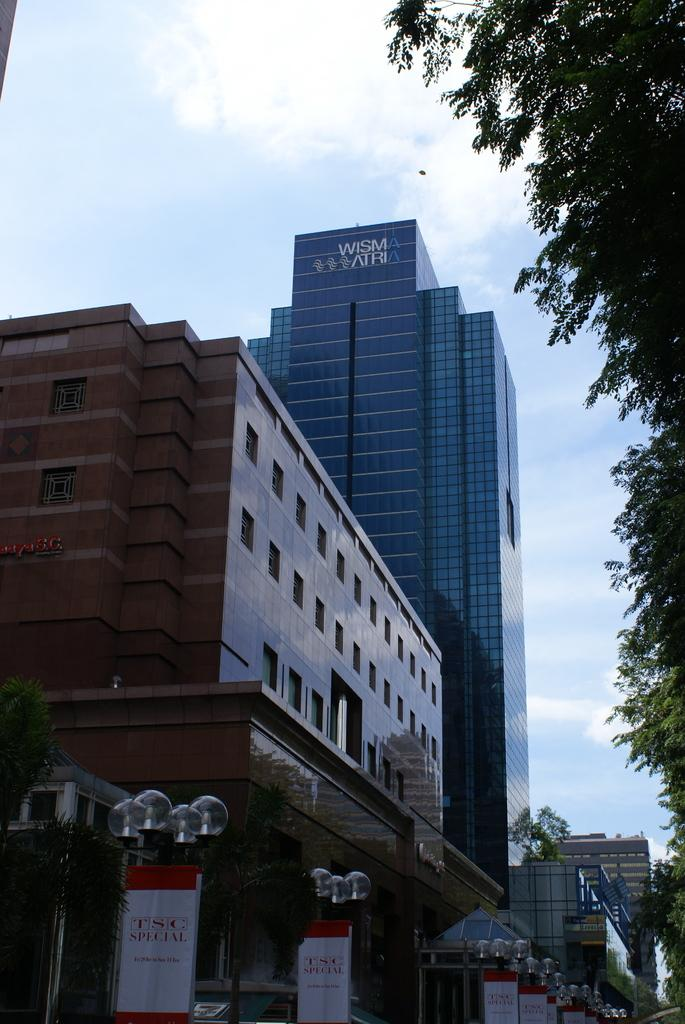Provide a one-sentence caption for the provided image. TSC Special banners are displayed on a street, where you can also see the side of the Wisma Atria building. 